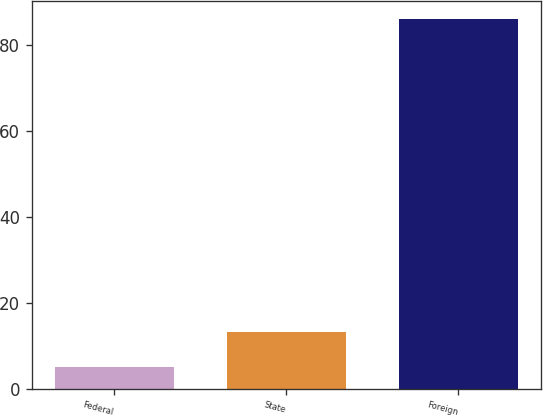Convert chart to OTSL. <chart><loc_0><loc_0><loc_500><loc_500><bar_chart><fcel>Federal<fcel>State<fcel>Foreign<nl><fcel>5<fcel>13.1<fcel>86<nl></chart> 